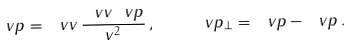<formula> <loc_0><loc_0><loc_500><loc_500>\ v p _ { \| } = \ v v \, \frac { \ v v \ v p } { v ^ { 2 } } \, , \quad \ v p _ { \perp } = \ v p - \ v p _ { \| } \, .</formula> 